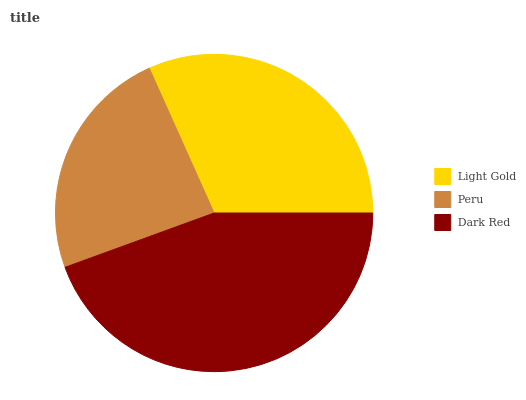Is Peru the minimum?
Answer yes or no. Yes. Is Dark Red the maximum?
Answer yes or no. Yes. Is Dark Red the minimum?
Answer yes or no. No. Is Peru the maximum?
Answer yes or no. No. Is Dark Red greater than Peru?
Answer yes or no. Yes. Is Peru less than Dark Red?
Answer yes or no. Yes. Is Peru greater than Dark Red?
Answer yes or no. No. Is Dark Red less than Peru?
Answer yes or no. No. Is Light Gold the high median?
Answer yes or no. Yes. Is Light Gold the low median?
Answer yes or no. Yes. Is Dark Red the high median?
Answer yes or no. No. Is Peru the low median?
Answer yes or no. No. 